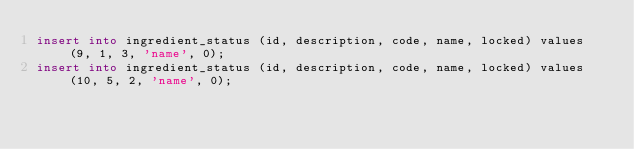Convert code to text. <code><loc_0><loc_0><loc_500><loc_500><_SQL_>insert into ingredient_status (id, description, code, name, locked) values (9, 1, 3, 'name', 0);
insert into ingredient_status (id, description, code, name, locked) values (10, 5, 2, 'name', 0);
</code> 